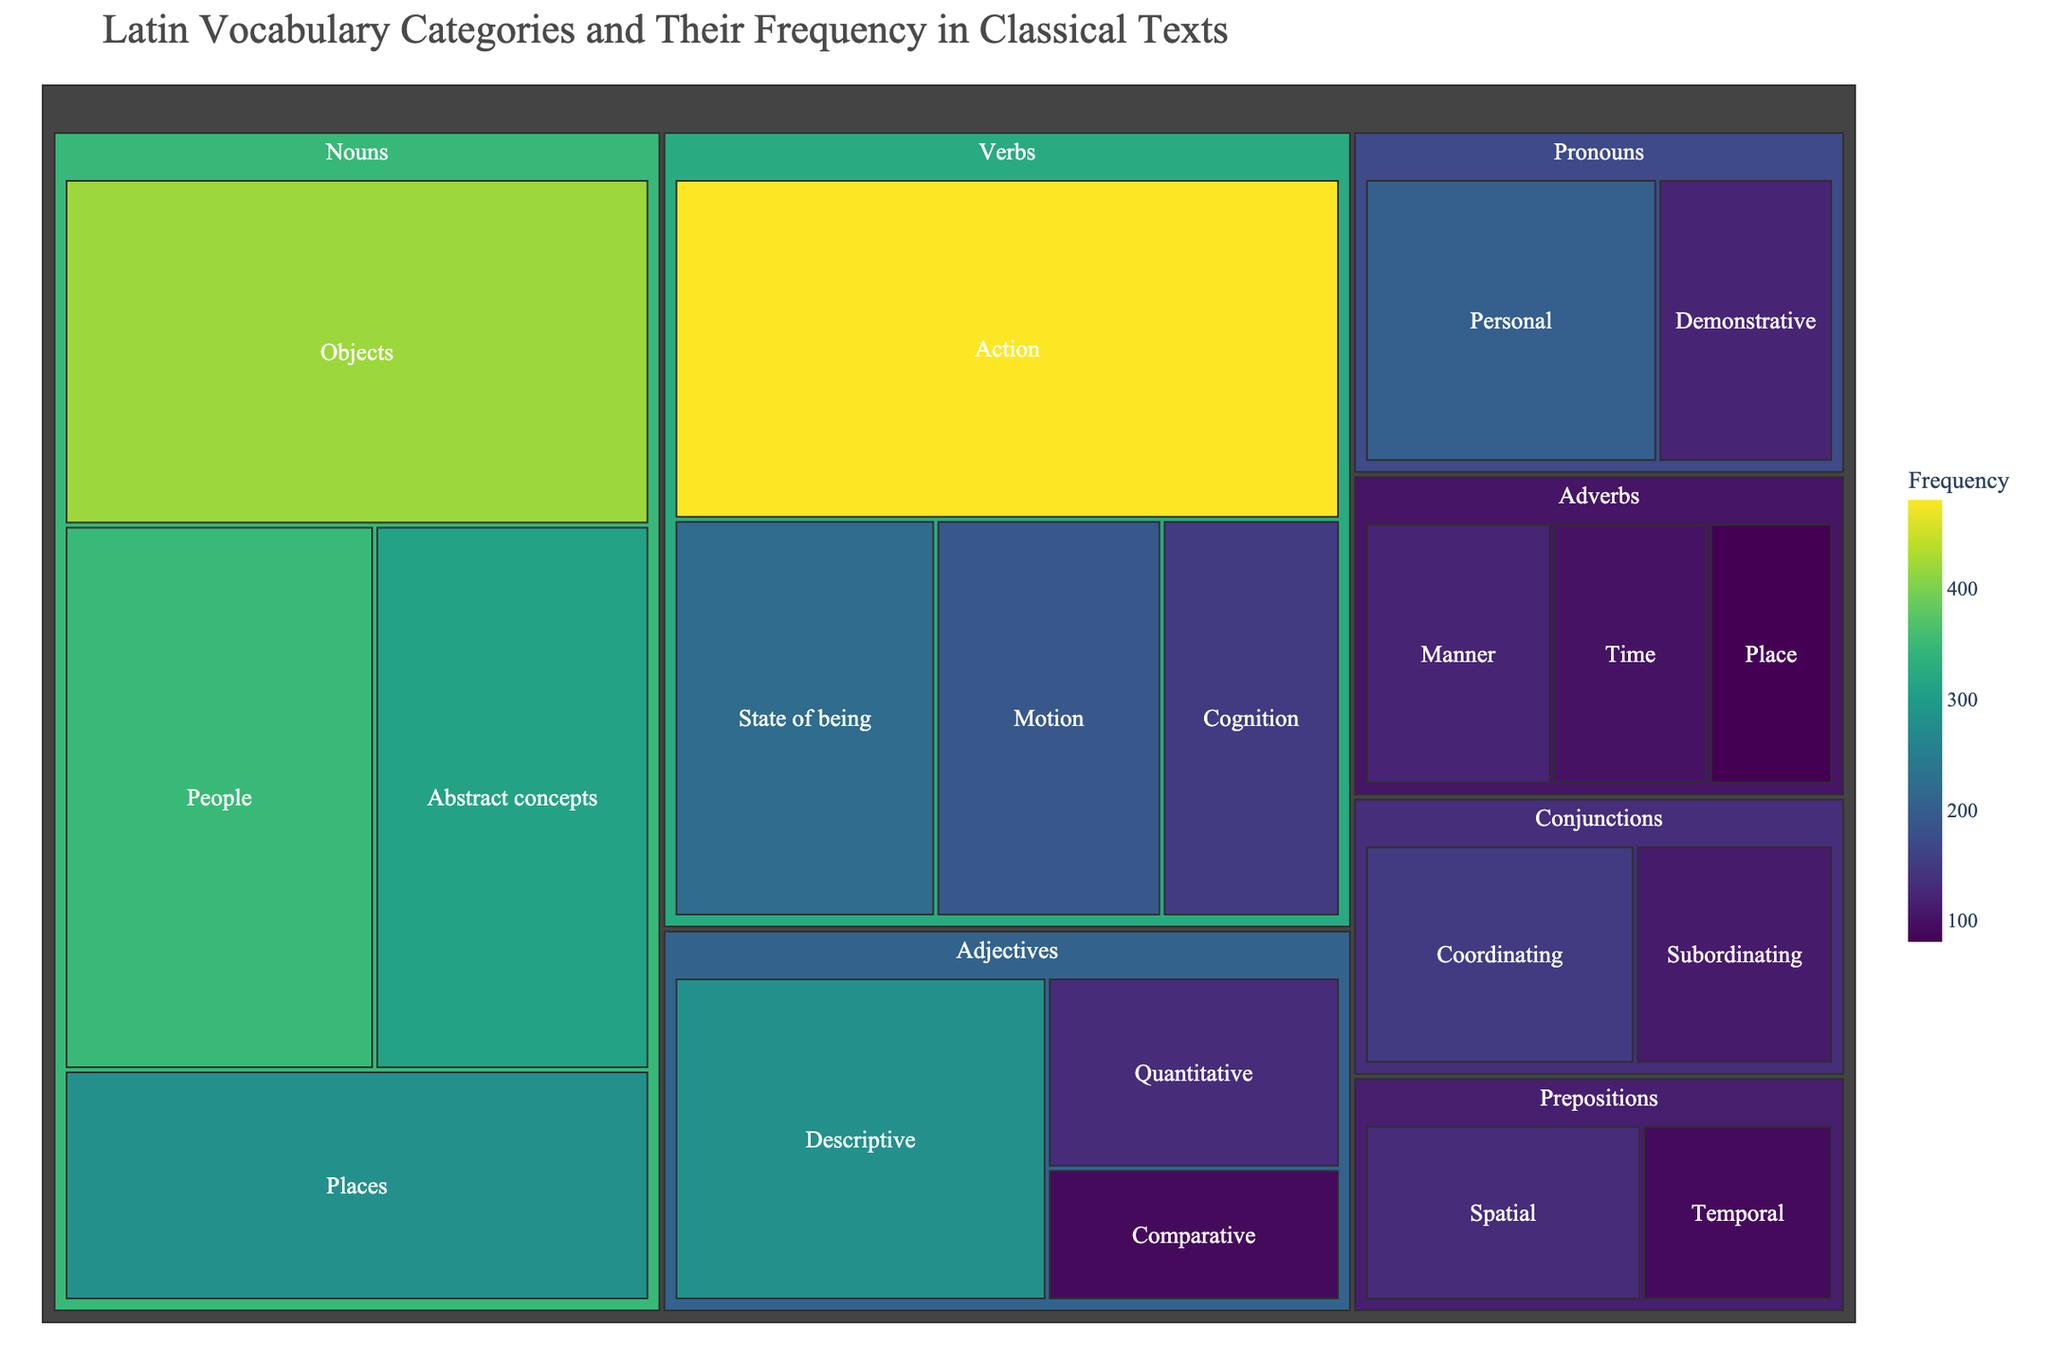what is the title of the figure? Look at the top of the figure for the title that summarizes the content.
Answer: "Latin Vocabulary Categories and Their Frequency in Classical Texts" Which category has the highest total frequency? Sum the frequencies for each subcategory under each category and compare the totals.
Answer: Verbs What is the frequency of the 'Descriptive' subcategory in Adjectives? Find the subcategory 'Descriptive' under the category 'Adjectives' and read its frequency.
Answer: 280 What is the combined frequency of 'Cognition' and 'Motion' in Verbs? Add the frequencies of the 'Cognition' and 'Motion' subcategories under Verbs: 150 + 190.
Answer: 340 Which subcategory has the lowest frequency? Find the subcategory with the smallest number among all categories.
Answer: Comparative (90) How does the frequency of 'Temporal' prepositions compare to 'Temporal' adverbs? Compare the frequencies of the 'Temporal' subcategories in Prepositions and Adverbs: 90 vs 100.
Answer: Temporal Adverbs have a higher frequency What is the difference in frequency between 'People' Nouns and 'Personal' Pronouns? Subtract the frequency of 'Personal' Pronouns from 'People' Nouns: 350 - 200.
Answer: 150 Among the subcategories in Nouns, which one has the second-highest frequency? Compare the frequencies in the Nouns category and identify the second largest value.
Answer: People (350) What is the average frequency of all the 'Adjectives' subcategories? Calculate the average by summing the frequencies for Descriptive, Quantitative, and Comparative and dividing by the number of subcategories: (280 + 130 + 90) / 3.
Answer: 166.67 What proportion of the total frequency does 'Action' verbs represent? Add all frequencies to find the total, then divide the 'Action' verbs frequency by the total: 480 / (sum of all subcategory frequencies).
Answer: `0.147část` 